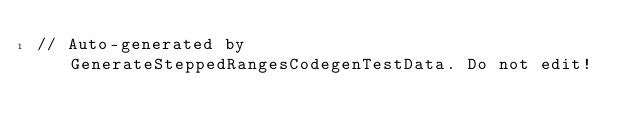Convert code to text. <code><loc_0><loc_0><loc_500><loc_500><_Kotlin_>// Auto-generated by GenerateSteppedRangesCodegenTestData. Do not edit!</code> 